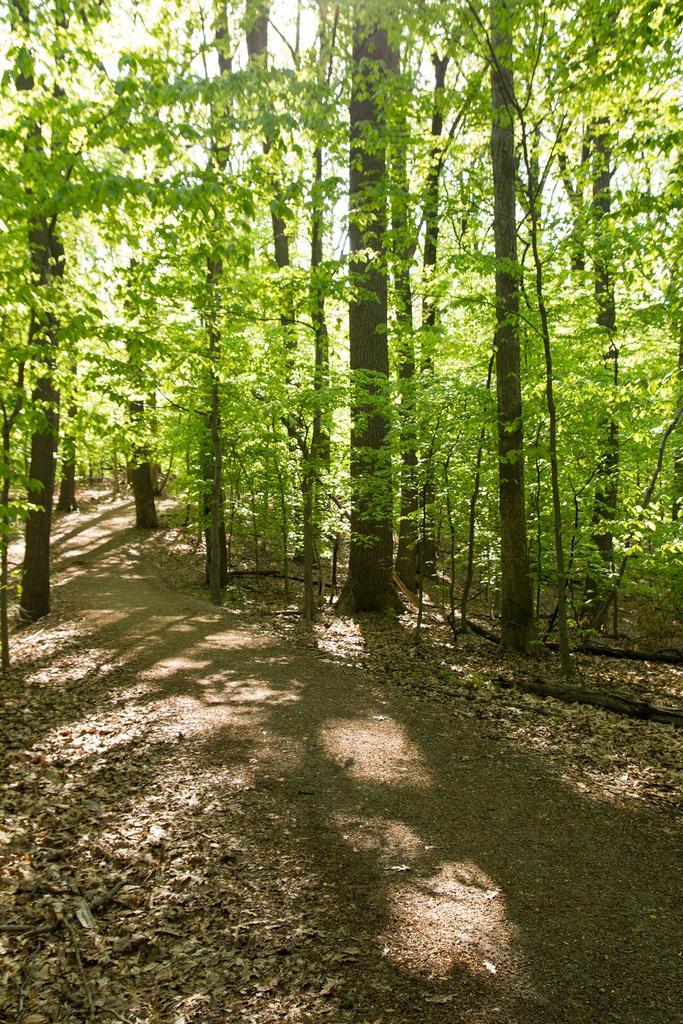Please provide a concise description of this image. In the image we can see some trees. At the bottom of the image there are some leaves. 